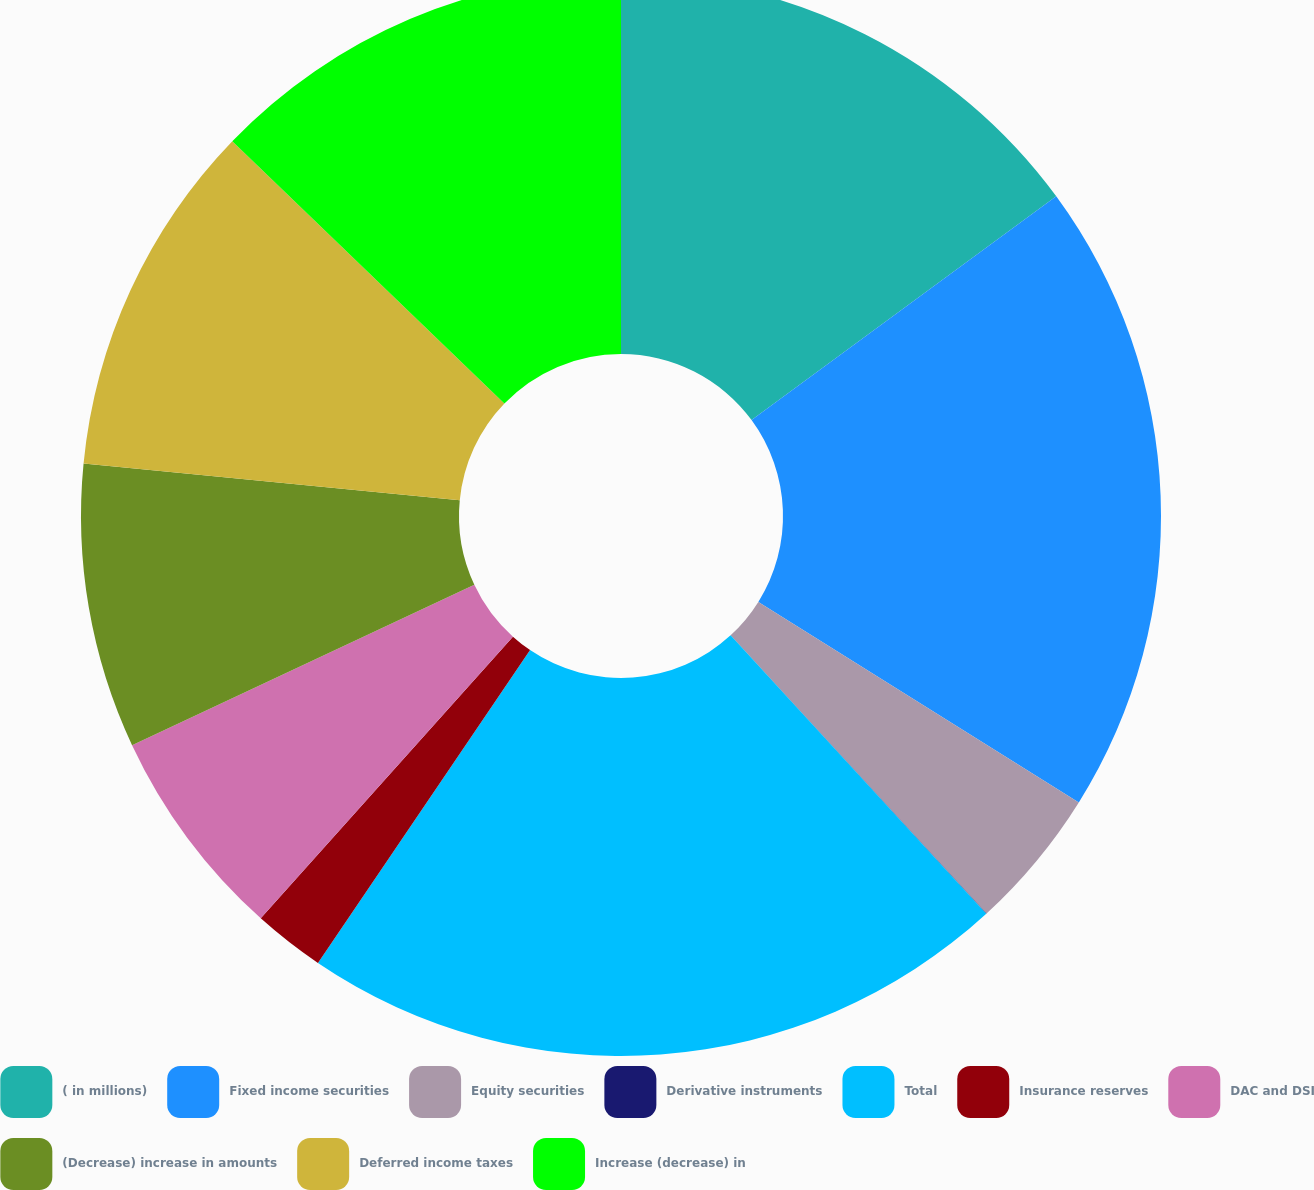<chart> <loc_0><loc_0><loc_500><loc_500><pie_chart><fcel>( in millions)<fcel>Fixed income securities<fcel>Equity securities<fcel>Derivative instruments<fcel>Total<fcel>Insurance reserves<fcel>DAC and DSI<fcel>(Decrease) increase in amounts<fcel>Deferred income taxes<fcel>Increase (decrease) in<nl><fcel>14.92%<fcel>18.98%<fcel>4.27%<fcel>0.01%<fcel>21.31%<fcel>2.14%<fcel>6.4%<fcel>8.53%<fcel>10.66%<fcel>12.79%<nl></chart> 